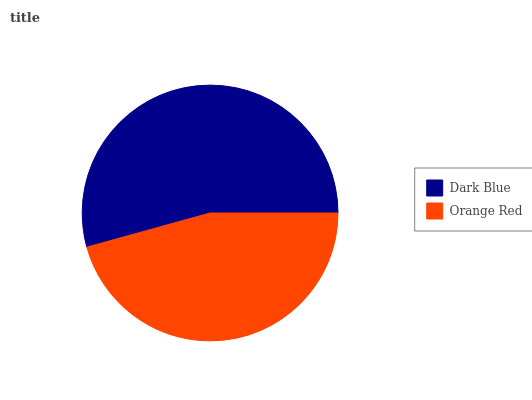Is Orange Red the minimum?
Answer yes or no. Yes. Is Dark Blue the maximum?
Answer yes or no. Yes. Is Orange Red the maximum?
Answer yes or no. No. Is Dark Blue greater than Orange Red?
Answer yes or no. Yes. Is Orange Red less than Dark Blue?
Answer yes or no. Yes. Is Orange Red greater than Dark Blue?
Answer yes or no. No. Is Dark Blue less than Orange Red?
Answer yes or no. No. Is Dark Blue the high median?
Answer yes or no. Yes. Is Orange Red the low median?
Answer yes or no. Yes. Is Orange Red the high median?
Answer yes or no. No. Is Dark Blue the low median?
Answer yes or no. No. 